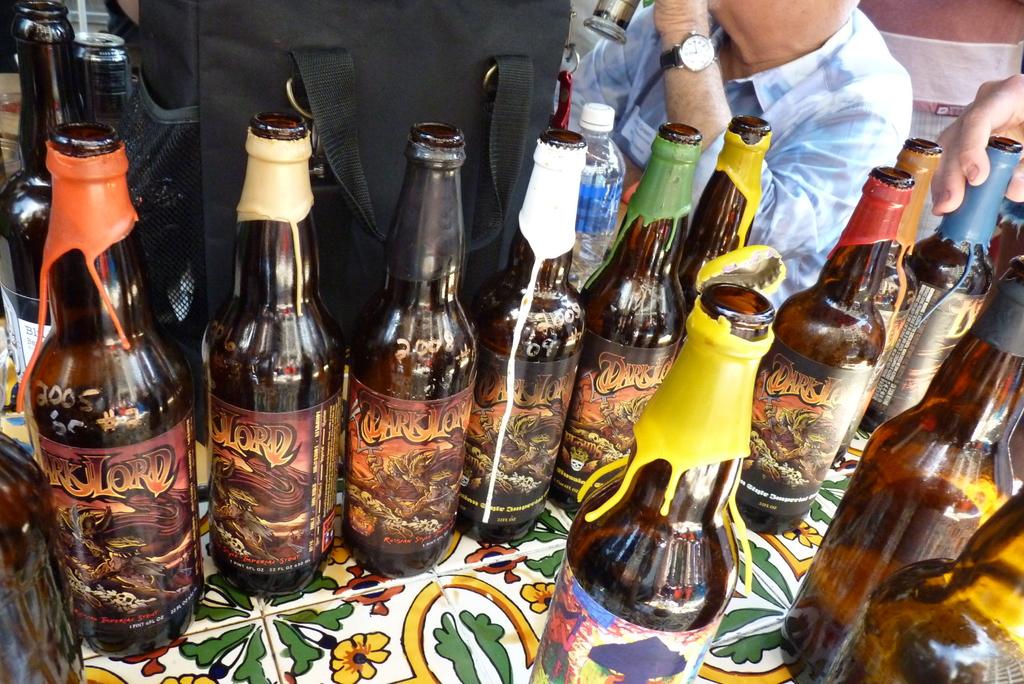What brand of beer is that?
Offer a very short reply. Dark lord. 